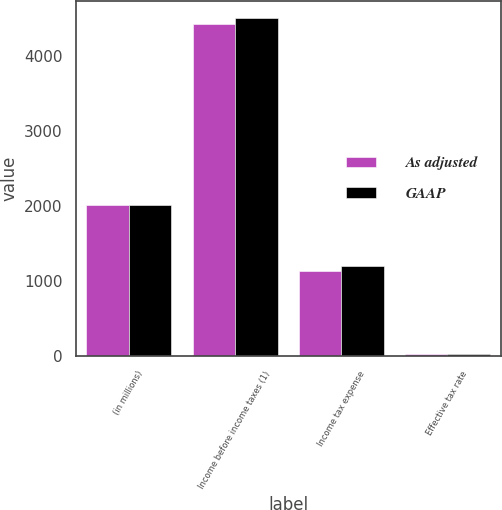Convert chart. <chart><loc_0><loc_0><loc_500><loc_500><stacked_bar_chart><ecel><fcel>(in millions)<fcel>Income before income taxes (1)<fcel>Income tax expense<fcel>Effective tax rate<nl><fcel>As adjusted<fcel>2014<fcel>4425<fcel>1131<fcel>25.6<nl><fcel>GAAP<fcel>2014<fcel>4507<fcel>1197<fcel>26.6<nl></chart> 